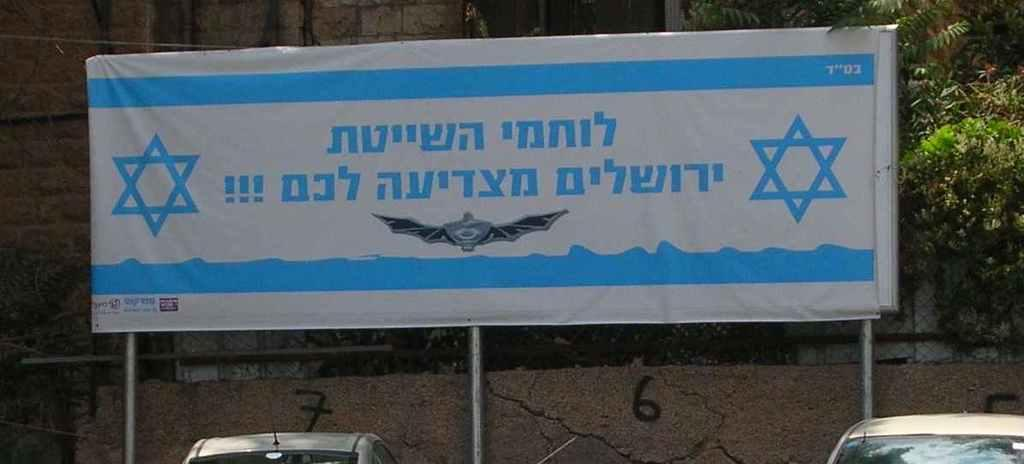What is written on in the image? There is written text on a board in the image. How many vehicles can be seen in the image? There are two vehicles in the image. What type of barrier is present in the image? There is a metal fence in the image. What type of structure is visible in the image? There is a wall in the image. What type of vegetation is present in the image? There are trees in the image. Can you describe the duck's behavior during the recess in the image? There is no duck present in the image, and therefore no duck behavior can be observed. How does the written text on the board aid in the digestion process in the image? The written text on the board does not relate to the digestion process, as it is unrelated to the image's content. 